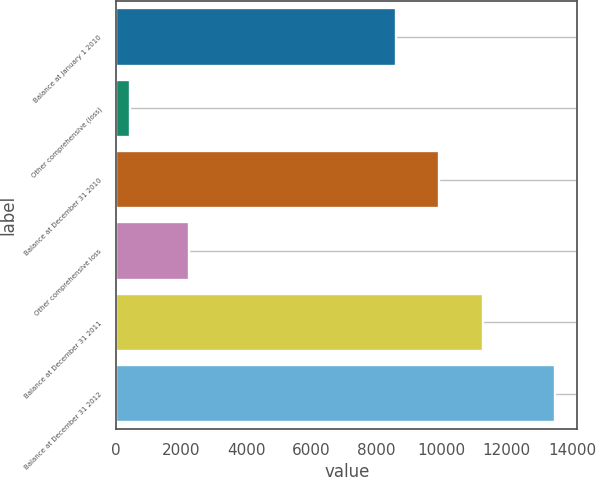Convert chart to OTSL. <chart><loc_0><loc_0><loc_500><loc_500><bar_chart><fcel>Balance at January 1 2010<fcel>Other comprehensive (loss)<fcel>Balance at December 31 2010<fcel>Other comprehensive loss<fcel>Balance at December 31 2011<fcel>Balance at December 31 2012<nl><fcel>8595<fcel>415<fcel>9902.8<fcel>2247<fcel>11257<fcel>13493<nl></chart> 